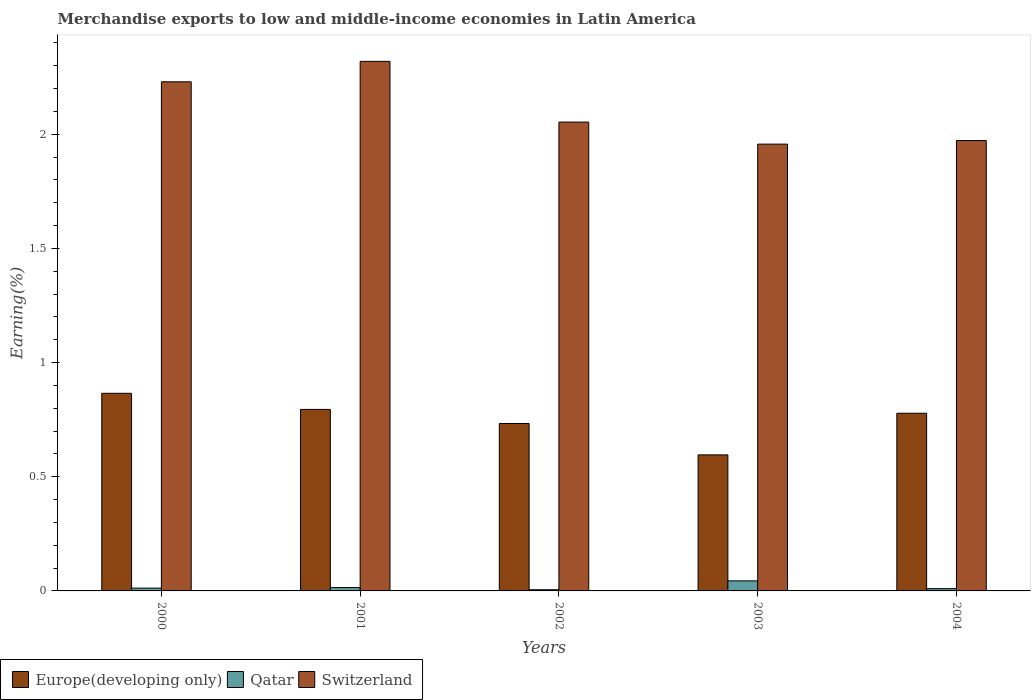Are the number of bars per tick equal to the number of legend labels?
Your answer should be very brief. Yes. Are the number of bars on each tick of the X-axis equal?
Give a very brief answer. Yes. How many bars are there on the 2nd tick from the left?
Provide a short and direct response. 3. What is the label of the 4th group of bars from the left?
Give a very brief answer. 2003. In how many cases, is the number of bars for a given year not equal to the number of legend labels?
Ensure brevity in your answer.  0. What is the percentage of amount earned from merchandise exports in Switzerland in 2001?
Provide a short and direct response. 2.32. Across all years, what is the maximum percentage of amount earned from merchandise exports in Qatar?
Your answer should be very brief. 0.04. Across all years, what is the minimum percentage of amount earned from merchandise exports in Europe(developing only)?
Provide a short and direct response. 0.6. In which year was the percentage of amount earned from merchandise exports in Switzerland minimum?
Provide a succinct answer. 2003. What is the total percentage of amount earned from merchandise exports in Europe(developing only) in the graph?
Your answer should be compact. 3.77. What is the difference between the percentage of amount earned from merchandise exports in Qatar in 2000 and that in 2001?
Offer a very short reply. -0. What is the difference between the percentage of amount earned from merchandise exports in Europe(developing only) in 2000 and the percentage of amount earned from merchandise exports in Qatar in 2004?
Ensure brevity in your answer.  0.86. What is the average percentage of amount earned from merchandise exports in Europe(developing only) per year?
Your response must be concise. 0.75. In the year 2002, what is the difference between the percentage of amount earned from merchandise exports in Switzerland and percentage of amount earned from merchandise exports in Qatar?
Offer a very short reply. 2.05. What is the ratio of the percentage of amount earned from merchandise exports in Qatar in 2002 to that in 2003?
Your answer should be very brief. 0.12. What is the difference between the highest and the second highest percentage of amount earned from merchandise exports in Europe(developing only)?
Provide a short and direct response. 0.07. What is the difference between the highest and the lowest percentage of amount earned from merchandise exports in Qatar?
Your response must be concise. 0.04. In how many years, is the percentage of amount earned from merchandise exports in Qatar greater than the average percentage of amount earned from merchandise exports in Qatar taken over all years?
Offer a terse response. 1. What does the 2nd bar from the left in 2000 represents?
Keep it short and to the point. Qatar. What does the 1st bar from the right in 2003 represents?
Your answer should be very brief. Switzerland. Is it the case that in every year, the sum of the percentage of amount earned from merchandise exports in Switzerland and percentage of amount earned from merchandise exports in Qatar is greater than the percentage of amount earned from merchandise exports in Europe(developing only)?
Give a very brief answer. Yes. How many bars are there?
Make the answer very short. 15. How many years are there in the graph?
Provide a short and direct response. 5. What is the difference between two consecutive major ticks on the Y-axis?
Your answer should be compact. 0.5. Are the values on the major ticks of Y-axis written in scientific E-notation?
Your answer should be compact. No. Does the graph contain any zero values?
Make the answer very short. No. Does the graph contain grids?
Keep it short and to the point. No. Where does the legend appear in the graph?
Provide a succinct answer. Bottom left. What is the title of the graph?
Your answer should be compact. Merchandise exports to low and middle-income economies in Latin America. Does "Comoros" appear as one of the legend labels in the graph?
Your response must be concise. No. What is the label or title of the Y-axis?
Your answer should be compact. Earning(%). What is the Earning(%) in Europe(developing only) in 2000?
Ensure brevity in your answer.  0.87. What is the Earning(%) in Qatar in 2000?
Give a very brief answer. 0.01. What is the Earning(%) of Switzerland in 2000?
Provide a short and direct response. 2.23. What is the Earning(%) in Europe(developing only) in 2001?
Give a very brief answer. 0.79. What is the Earning(%) in Qatar in 2001?
Offer a very short reply. 0.01. What is the Earning(%) in Switzerland in 2001?
Provide a succinct answer. 2.32. What is the Earning(%) in Europe(developing only) in 2002?
Provide a short and direct response. 0.73. What is the Earning(%) in Qatar in 2002?
Offer a terse response. 0.01. What is the Earning(%) of Switzerland in 2002?
Provide a succinct answer. 2.05. What is the Earning(%) of Europe(developing only) in 2003?
Offer a terse response. 0.6. What is the Earning(%) of Qatar in 2003?
Offer a terse response. 0.04. What is the Earning(%) of Switzerland in 2003?
Make the answer very short. 1.96. What is the Earning(%) of Europe(developing only) in 2004?
Provide a succinct answer. 0.78. What is the Earning(%) of Qatar in 2004?
Your answer should be very brief. 0.01. What is the Earning(%) in Switzerland in 2004?
Your answer should be very brief. 1.97. Across all years, what is the maximum Earning(%) of Europe(developing only)?
Make the answer very short. 0.87. Across all years, what is the maximum Earning(%) in Qatar?
Offer a very short reply. 0.04. Across all years, what is the maximum Earning(%) of Switzerland?
Your response must be concise. 2.32. Across all years, what is the minimum Earning(%) in Europe(developing only)?
Offer a terse response. 0.6. Across all years, what is the minimum Earning(%) of Qatar?
Keep it short and to the point. 0.01. Across all years, what is the minimum Earning(%) of Switzerland?
Offer a very short reply. 1.96. What is the total Earning(%) in Europe(developing only) in the graph?
Your answer should be very brief. 3.77. What is the total Earning(%) in Qatar in the graph?
Offer a terse response. 0.09. What is the total Earning(%) in Switzerland in the graph?
Your answer should be compact. 10.53. What is the difference between the Earning(%) in Europe(developing only) in 2000 and that in 2001?
Offer a terse response. 0.07. What is the difference between the Earning(%) in Qatar in 2000 and that in 2001?
Ensure brevity in your answer.  -0. What is the difference between the Earning(%) of Switzerland in 2000 and that in 2001?
Keep it short and to the point. -0.09. What is the difference between the Earning(%) in Europe(developing only) in 2000 and that in 2002?
Provide a succinct answer. 0.13. What is the difference between the Earning(%) in Qatar in 2000 and that in 2002?
Ensure brevity in your answer.  0.01. What is the difference between the Earning(%) of Switzerland in 2000 and that in 2002?
Your answer should be compact. 0.18. What is the difference between the Earning(%) of Europe(developing only) in 2000 and that in 2003?
Your answer should be compact. 0.27. What is the difference between the Earning(%) of Qatar in 2000 and that in 2003?
Ensure brevity in your answer.  -0.03. What is the difference between the Earning(%) in Switzerland in 2000 and that in 2003?
Ensure brevity in your answer.  0.27. What is the difference between the Earning(%) in Europe(developing only) in 2000 and that in 2004?
Your answer should be very brief. 0.09. What is the difference between the Earning(%) in Qatar in 2000 and that in 2004?
Give a very brief answer. 0. What is the difference between the Earning(%) in Switzerland in 2000 and that in 2004?
Give a very brief answer. 0.26. What is the difference between the Earning(%) of Europe(developing only) in 2001 and that in 2002?
Make the answer very short. 0.06. What is the difference between the Earning(%) in Qatar in 2001 and that in 2002?
Your answer should be compact. 0.01. What is the difference between the Earning(%) in Switzerland in 2001 and that in 2002?
Provide a short and direct response. 0.27. What is the difference between the Earning(%) of Europe(developing only) in 2001 and that in 2003?
Ensure brevity in your answer.  0.2. What is the difference between the Earning(%) in Qatar in 2001 and that in 2003?
Your answer should be compact. -0.03. What is the difference between the Earning(%) of Switzerland in 2001 and that in 2003?
Ensure brevity in your answer.  0.36. What is the difference between the Earning(%) in Europe(developing only) in 2001 and that in 2004?
Your answer should be very brief. 0.02. What is the difference between the Earning(%) of Qatar in 2001 and that in 2004?
Provide a succinct answer. 0. What is the difference between the Earning(%) of Switzerland in 2001 and that in 2004?
Your response must be concise. 0.35. What is the difference between the Earning(%) in Europe(developing only) in 2002 and that in 2003?
Offer a very short reply. 0.14. What is the difference between the Earning(%) of Qatar in 2002 and that in 2003?
Ensure brevity in your answer.  -0.04. What is the difference between the Earning(%) in Switzerland in 2002 and that in 2003?
Give a very brief answer. 0.1. What is the difference between the Earning(%) in Europe(developing only) in 2002 and that in 2004?
Make the answer very short. -0.04. What is the difference between the Earning(%) in Qatar in 2002 and that in 2004?
Your response must be concise. -0. What is the difference between the Earning(%) of Switzerland in 2002 and that in 2004?
Offer a terse response. 0.08. What is the difference between the Earning(%) of Europe(developing only) in 2003 and that in 2004?
Your answer should be very brief. -0.18. What is the difference between the Earning(%) of Qatar in 2003 and that in 2004?
Offer a very short reply. 0.03. What is the difference between the Earning(%) of Switzerland in 2003 and that in 2004?
Ensure brevity in your answer.  -0.02. What is the difference between the Earning(%) of Europe(developing only) in 2000 and the Earning(%) of Qatar in 2001?
Offer a very short reply. 0.85. What is the difference between the Earning(%) of Europe(developing only) in 2000 and the Earning(%) of Switzerland in 2001?
Your response must be concise. -1.45. What is the difference between the Earning(%) in Qatar in 2000 and the Earning(%) in Switzerland in 2001?
Your response must be concise. -2.31. What is the difference between the Earning(%) of Europe(developing only) in 2000 and the Earning(%) of Qatar in 2002?
Your response must be concise. 0.86. What is the difference between the Earning(%) of Europe(developing only) in 2000 and the Earning(%) of Switzerland in 2002?
Provide a short and direct response. -1.19. What is the difference between the Earning(%) in Qatar in 2000 and the Earning(%) in Switzerland in 2002?
Your answer should be very brief. -2.04. What is the difference between the Earning(%) of Europe(developing only) in 2000 and the Earning(%) of Qatar in 2003?
Provide a succinct answer. 0.82. What is the difference between the Earning(%) of Europe(developing only) in 2000 and the Earning(%) of Switzerland in 2003?
Your response must be concise. -1.09. What is the difference between the Earning(%) in Qatar in 2000 and the Earning(%) in Switzerland in 2003?
Your answer should be compact. -1.94. What is the difference between the Earning(%) of Europe(developing only) in 2000 and the Earning(%) of Qatar in 2004?
Provide a short and direct response. 0.86. What is the difference between the Earning(%) of Europe(developing only) in 2000 and the Earning(%) of Switzerland in 2004?
Your answer should be very brief. -1.11. What is the difference between the Earning(%) of Qatar in 2000 and the Earning(%) of Switzerland in 2004?
Offer a terse response. -1.96. What is the difference between the Earning(%) in Europe(developing only) in 2001 and the Earning(%) in Qatar in 2002?
Your answer should be compact. 0.79. What is the difference between the Earning(%) of Europe(developing only) in 2001 and the Earning(%) of Switzerland in 2002?
Offer a terse response. -1.26. What is the difference between the Earning(%) in Qatar in 2001 and the Earning(%) in Switzerland in 2002?
Your answer should be compact. -2.04. What is the difference between the Earning(%) of Europe(developing only) in 2001 and the Earning(%) of Qatar in 2003?
Your answer should be compact. 0.75. What is the difference between the Earning(%) in Europe(developing only) in 2001 and the Earning(%) in Switzerland in 2003?
Give a very brief answer. -1.16. What is the difference between the Earning(%) in Qatar in 2001 and the Earning(%) in Switzerland in 2003?
Provide a short and direct response. -1.94. What is the difference between the Earning(%) of Europe(developing only) in 2001 and the Earning(%) of Qatar in 2004?
Your answer should be compact. 0.79. What is the difference between the Earning(%) of Europe(developing only) in 2001 and the Earning(%) of Switzerland in 2004?
Your response must be concise. -1.18. What is the difference between the Earning(%) in Qatar in 2001 and the Earning(%) in Switzerland in 2004?
Your response must be concise. -1.96. What is the difference between the Earning(%) in Europe(developing only) in 2002 and the Earning(%) in Qatar in 2003?
Keep it short and to the point. 0.69. What is the difference between the Earning(%) in Europe(developing only) in 2002 and the Earning(%) in Switzerland in 2003?
Offer a terse response. -1.22. What is the difference between the Earning(%) of Qatar in 2002 and the Earning(%) of Switzerland in 2003?
Ensure brevity in your answer.  -1.95. What is the difference between the Earning(%) of Europe(developing only) in 2002 and the Earning(%) of Qatar in 2004?
Keep it short and to the point. 0.72. What is the difference between the Earning(%) of Europe(developing only) in 2002 and the Earning(%) of Switzerland in 2004?
Give a very brief answer. -1.24. What is the difference between the Earning(%) of Qatar in 2002 and the Earning(%) of Switzerland in 2004?
Ensure brevity in your answer.  -1.97. What is the difference between the Earning(%) of Europe(developing only) in 2003 and the Earning(%) of Qatar in 2004?
Make the answer very short. 0.59. What is the difference between the Earning(%) of Europe(developing only) in 2003 and the Earning(%) of Switzerland in 2004?
Provide a short and direct response. -1.38. What is the difference between the Earning(%) of Qatar in 2003 and the Earning(%) of Switzerland in 2004?
Keep it short and to the point. -1.93. What is the average Earning(%) in Europe(developing only) per year?
Ensure brevity in your answer.  0.75. What is the average Earning(%) in Qatar per year?
Keep it short and to the point. 0.02. What is the average Earning(%) of Switzerland per year?
Offer a very short reply. 2.11. In the year 2000, what is the difference between the Earning(%) of Europe(developing only) and Earning(%) of Qatar?
Your answer should be compact. 0.85. In the year 2000, what is the difference between the Earning(%) in Europe(developing only) and Earning(%) in Switzerland?
Your response must be concise. -1.36. In the year 2000, what is the difference between the Earning(%) in Qatar and Earning(%) in Switzerland?
Your answer should be compact. -2.22. In the year 2001, what is the difference between the Earning(%) in Europe(developing only) and Earning(%) in Qatar?
Your answer should be very brief. 0.78. In the year 2001, what is the difference between the Earning(%) of Europe(developing only) and Earning(%) of Switzerland?
Your response must be concise. -1.52. In the year 2001, what is the difference between the Earning(%) of Qatar and Earning(%) of Switzerland?
Offer a very short reply. -2.3. In the year 2002, what is the difference between the Earning(%) of Europe(developing only) and Earning(%) of Qatar?
Provide a succinct answer. 0.73. In the year 2002, what is the difference between the Earning(%) of Europe(developing only) and Earning(%) of Switzerland?
Provide a short and direct response. -1.32. In the year 2002, what is the difference between the Earning(%) of Qatar and Earning(%) of Switzerland?
Ensure brevity in your answer.  -2.05. In the year 2003, what is the difference between the Earning(%) of Europe(developing only) and Earning(%) of Qatar?
Provide a succinct answer. 0.55. In the year 2003, what is the difference between the Earning(%) in Europe(developing only) and Earning(%) in Switzerland?
Give a very brief answer. -1.36. In the year 2003, what is the difference between the Earning(%) of Qatar and Earning(%) of Switzerland?
Offer a very short reply. -1.91. In the year 2004, what is the difference between the Earning(%) in Europe(developing only) and Earning(%) in Qatar?
Offer a very short reply. 0.77. In the year 2004, what is the difference between the Earning(%) of Europe(developing only) and Earning(%) of Switzerland?
Offer a terse response. -1.19. In the year 2004, what is the difference between the Earning(%) in Qatar and Earning(%) in Switzerland?
Offer a very short reply. -1.96. What is the ratio of the Earning(%) in Europe(developing only) in 2000 to that in 2001?
Offer a terse response. 1.09. What is the ratio of the Earning(%) of Qatar in 2000 to that in 2001?
Provide a succinct answer. 0.83. What is the ratio of the Earning(%) of Switzerland in 2000 to that in 2001?
Offer a very short reply. 0.96. What is the ratio of the Earning(%) in Europe(developing only) in 2000 to that in 2002?
Your answer should be very brief. 1.18. What is the ratio of the Earning(%) in Qatar in 2000 to that in 2002?
Your answer should be compact. 2.36. What is the ratio of the Earning(%) in Switzerland in 2000 to that in 2002?
Your answer should be compact. 1.09. What is the ratio of the Earning(%) in Europe(developing only) in 2000 to that in 2003?
Your answer should be very brief. 1.45. What is the ratio of the Earning(%) of Qatar in 2000 to that in 2003?
Your answer should be compact. 0.28. What is the ratio of the Earning(%) of Switzerland in 2000 to that in 2003?
Keep it short and to the point. 1.14. What is the ratio of the Earning(%) of Europe(developing only) in 2000 to that in 2004?
Offer a terse response. 1.11. What is the ratio of the Earning(%) of Qatar in 2000 to that in 2004?
Provide a short and direct response. 1.23. What is the ratio of the Earning(%) of Switzerland in 2000 to that in 2004?
Provide a succinct answer. 1.13. What is the ratio of the Earning(%) of Europe(developing only) in 2001 to that in 2002?
Ensure brevity in your answer.  1.08. What is the ratio of the Earning(%) in Qatar in 2001 to that in 2002?
Provide a succinct answer. 2.84. What is the ratio of the Earning(%) in Switzerland in 2001 to that in 2002?
Offer a terse response. 1.13. What is the ratio of the Earning(%) of Europe(developing only) in 2001 to that in 2003?
Provide a succinct answer. 1.33. What is the ratio of the Earning(%) of Qatar in 2001 to that in 2003?
Give a very brief answer. 0.34. What is the ratio of the Earning(%) in Switzerland in 2001 to that in 2003?
Make the answer very short. 1.19. What is the ratio of the Earning(%) in Europe(developing only) in 2001 to that in 2004?
Your answer should be compact. 1.02. What is the ratio of the Earning(%) in Qatar in 2001 to that in 2004?
Give a very brief answer. 1.48. What is the ratio of the Earning(%) of Switzerland in 2001 to that in 2004?
Your response must be concise. 1.18. What is the ratio of the Earning(%) in Europe(developing only) in 2002 to that in 2003?
Provide a short and direct response. 1.23. What is the ratio of the Earning(%) in Qatar in 2002 to that in 2003?
Provide a short and direct response. 0.12. What is the ratio of the Earning(%) in Switzerland in 2002 to that in 2003?
Provide a succinct answer. 1.05. What is the ratio of the Earning(%) in Europe(developing only) in 2002 to that in 2004?
Give a very brief answer. 0.94. What is the ratio of the Earning(%) of Qatar in 2002 to that in 2004?
Offer a very short reply. 0.52. What is the ratio of the Earning(%) of Switzerland in 2002 to that in 2004?
Your answer should be compact. 1.04. What is the ratio of the Earning(%) of Europe(developing only) in 2003 to that in 2004?
Give a very brief answer. 0.77. What is the ratio of the Earning(%) in Qatar in 2003 to that in 2004?
Provide a short and direct response. 4.4. What is the difference between the highest and the second highest Earning(%) in Europe(developing only)?
Your response must be concise. 0.07. What is the difference between the highest and the second highest Earning(%) in Qatar?
Provide a succinct answer. 0.03. What is the difference between the highest and the second highest Earning(%) of Switzerland?
Your answer should be very brief. 0.09. What is the difference between the highest and the lowest Earning(%) of Europe(developing only)?
Give a very brief answer. 0.27. What is the difference between the highest and the lowest Earning(%) of Qatar?
Give a very brief answer. 0.04. What is the difference between the highest and the lowest Earning(%) of Switzerland?
Offer a terse response. 0.36. 